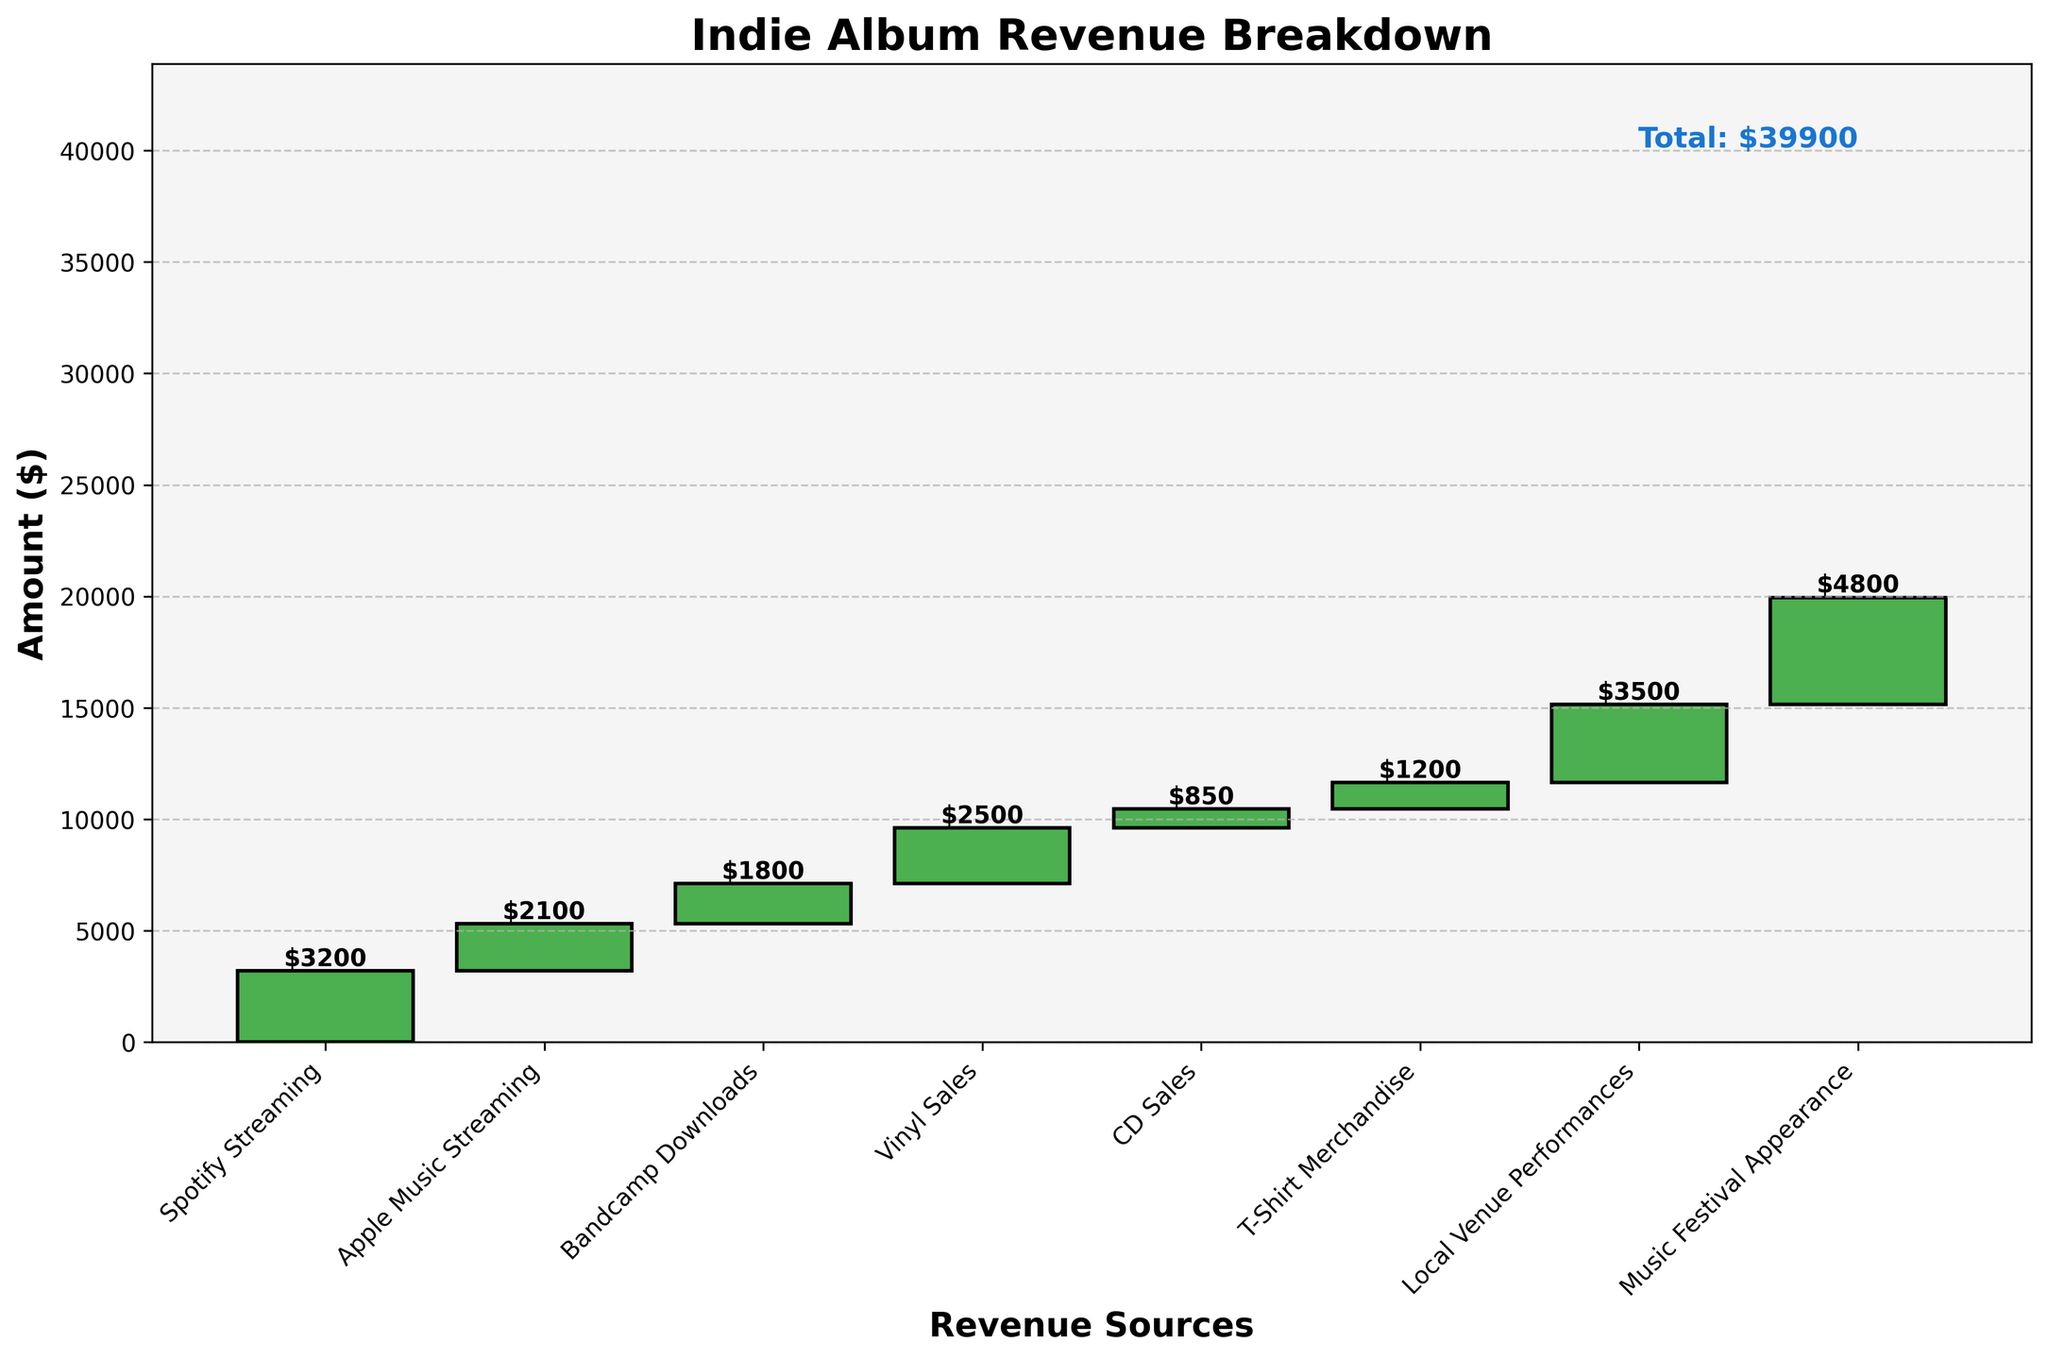How much revenue did Spotify streaming contribute? Look for the bar labeled "Spotify Streaming" and check the value label on top of the bar.
Answer: $3200 Which revenue source contributed the highest amount? Compare all the values of the bars representing different revenue sources. The bar for "Music Festival Appearance" has the highest value.
Answer: Music Festival Appearance What is the overall revenue from streaming services? Sum the values labeled "Spotify Streaming" and "Apple Music Streaming". $3200 + $2100 = $5300
Answer: $5300 What's the total revenue from physical sales? Add the values for "Vinyl Sales" and "CD Sales". $2500 + $850 = $3350
Answer: $3350 Does Bandcamp Downloads contribute more or less than Merchandise sales? Compare the values labeled "Bandcamp Downloads" and "T-Shirt Merchandise". $1800 vs. $1200, so Bandcamp Downloads contribute more.
Answer: More What is the total amount contributed by live performances? Sum the values labeled "Local Venue Performances" and "Music Festival Appearance". $3500 + $4800 = $8300
Answer: $8300 Was the total revenue exactly $20,000? Check the total revenue at the end of the breakdown. It is $19950, which is not exactly $20,000.
Answer: No Which streaming service contributed more revenue? Compare the values labeled "Spotify Streaming" and "Apple Music Streaming". $3200 is greater than $2100.
Answer: Spotify How much more did Music Festival Appearance contribute compared to Local Venue Performances? Subtract the value of Local Venue Performances from Music Festival Appearance. $4800 - $3500 = $1300
Answer: $1300 What is the smallest revenue source on the chart? Identify the bar with the smallest value. The "CD Sales" bar has the smallest value of $850.
Answer: CD Sales 